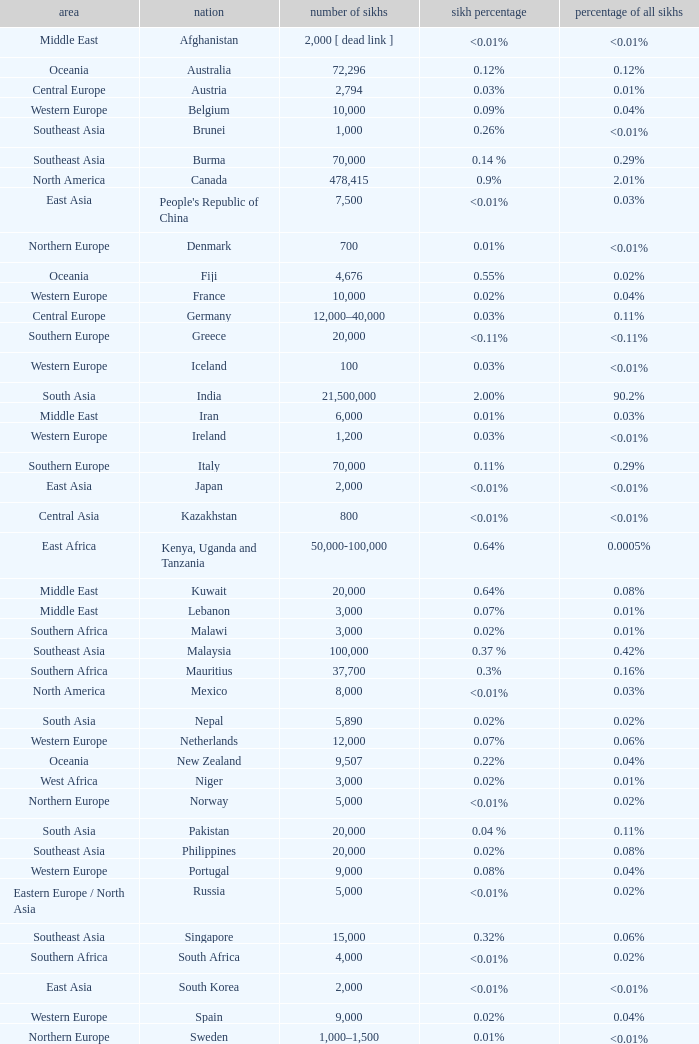What is the number of sikhs in Japan? 2000.0. 